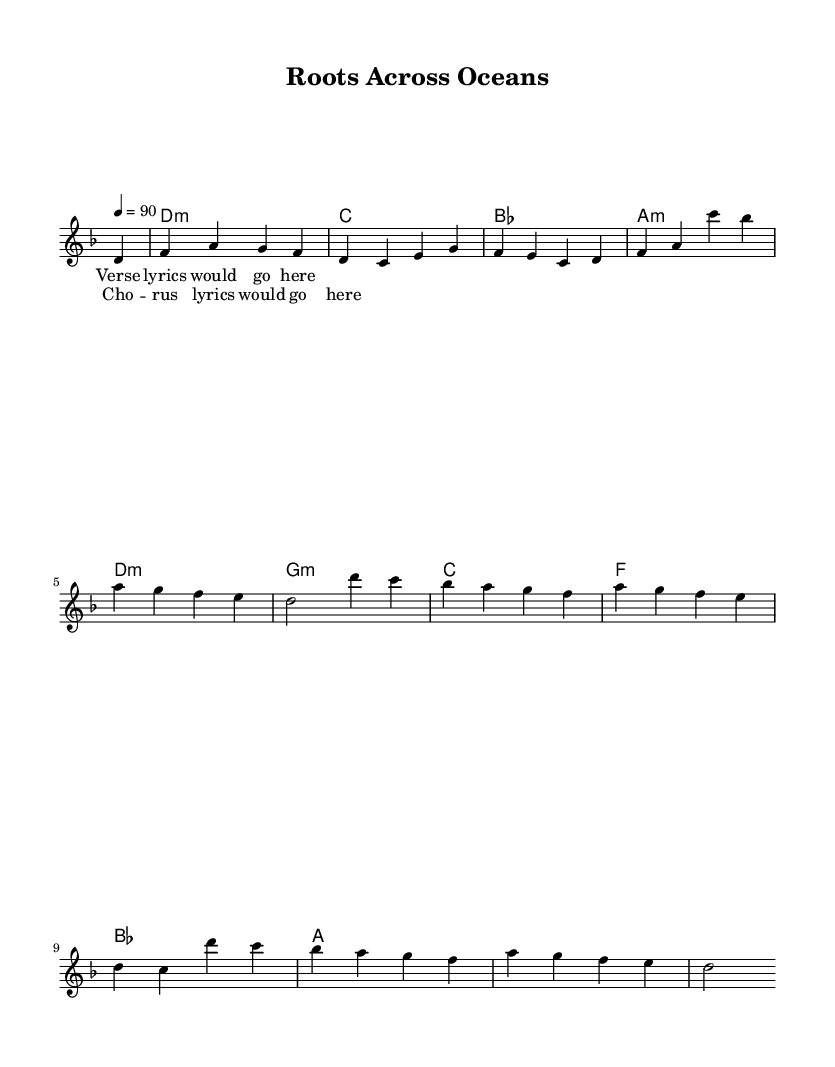What is the key signature of this music? The key signature indicates D minor, which typically includes one flat (C). This can be inferred from the key indication at the beginning of the piece, which is shown as 'd' minor.
Answer: D minor What is the time signature of this music? The time signature is 4/4, indicated by the two numbers at the beginning: the top number (4) shows there are four beats in a measure, and the bottom number (4) indicates a quarter note gets one beat.
Answer: 4/4 What is the tempo marking for the song? The tempo marking shows the speed of the piece intended by the composer, which is set at quarter note = 90. This means there should be 90 beats per minute.
Answer: 90 How many measures are in the melody section? The melody section contains a total of 8 measures as can be counted from the written music. Each line of music usually consists of 4 measures, and there are 2 such lines here.
Answer: 8 What type of chords are present at the start of the piece? The chord at the start is D minor, indicated by 'd1:m' in the harmonies section. This suggests a minor chord is played at the beginning of the music.
Answer: D minor How many voices are in the score? There is one lead voice in the score indicated clearly at the beginning of the voice part, which is used for the melody.
Answer: 1 What are the common themes explored in the lyrics for this genre? While the specific lyrics are not provided, typical themes in pop music, particularly from the South Asian diaspora, often explore cultural identity, heritage, love, and belonging. This assumption is based on the common characteristics of the genre.
Answer: Cultural identity and heritage 